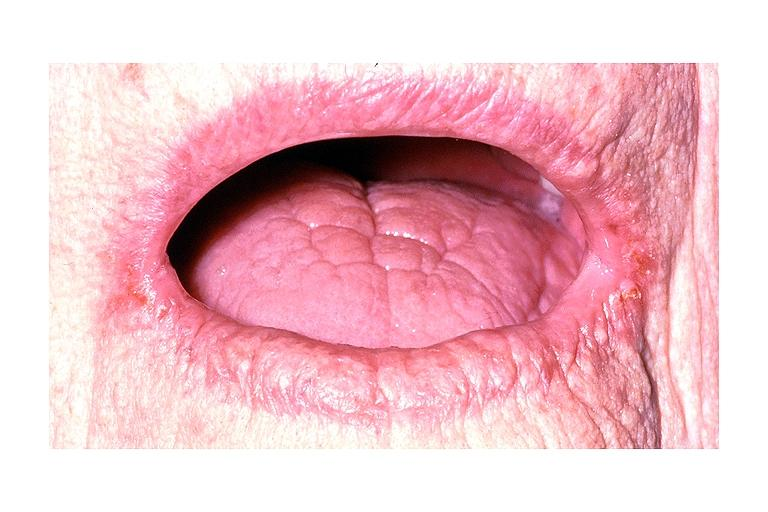does this image show angular chelitis?
Answer the question using a single word or phrase. Yes 